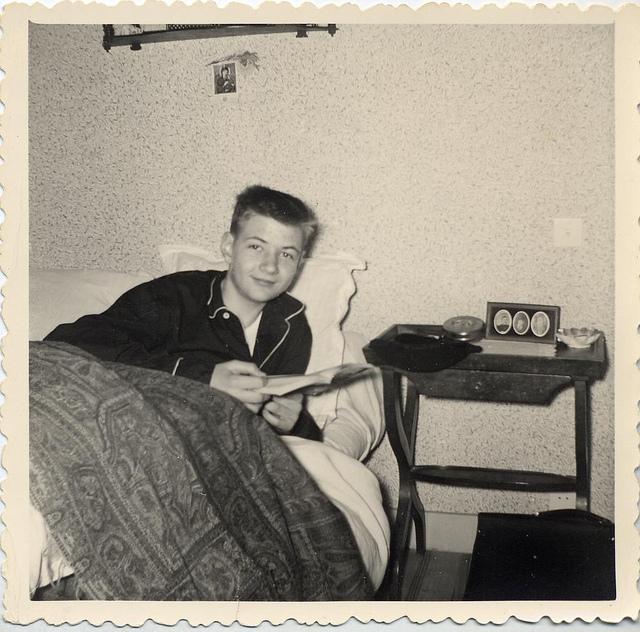Is the man standing?
Write a very short answer. No. What is the photo border called?
Write a very short answer. Border. Is this photo old?
Keep it brief. Yes. Is the camera that took this picture from the same era of history as the boy's activity?
Be succinct. Yes. 